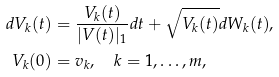Convert formula to latex. <formula><loc_0><loc_0><loc_500><loc_500>d V _ { k } ( t ) & = \frac { V _ { k } ( t ) } { | V ( t ) | _ { 1 } } d t + \sqrt { V _ { k } ( t ) } d W _ { k } ( t ) , \\ V _ { k } ( 0 ) & = v _ { k } , \quad k = 1 , \dots , m ,</formula> 